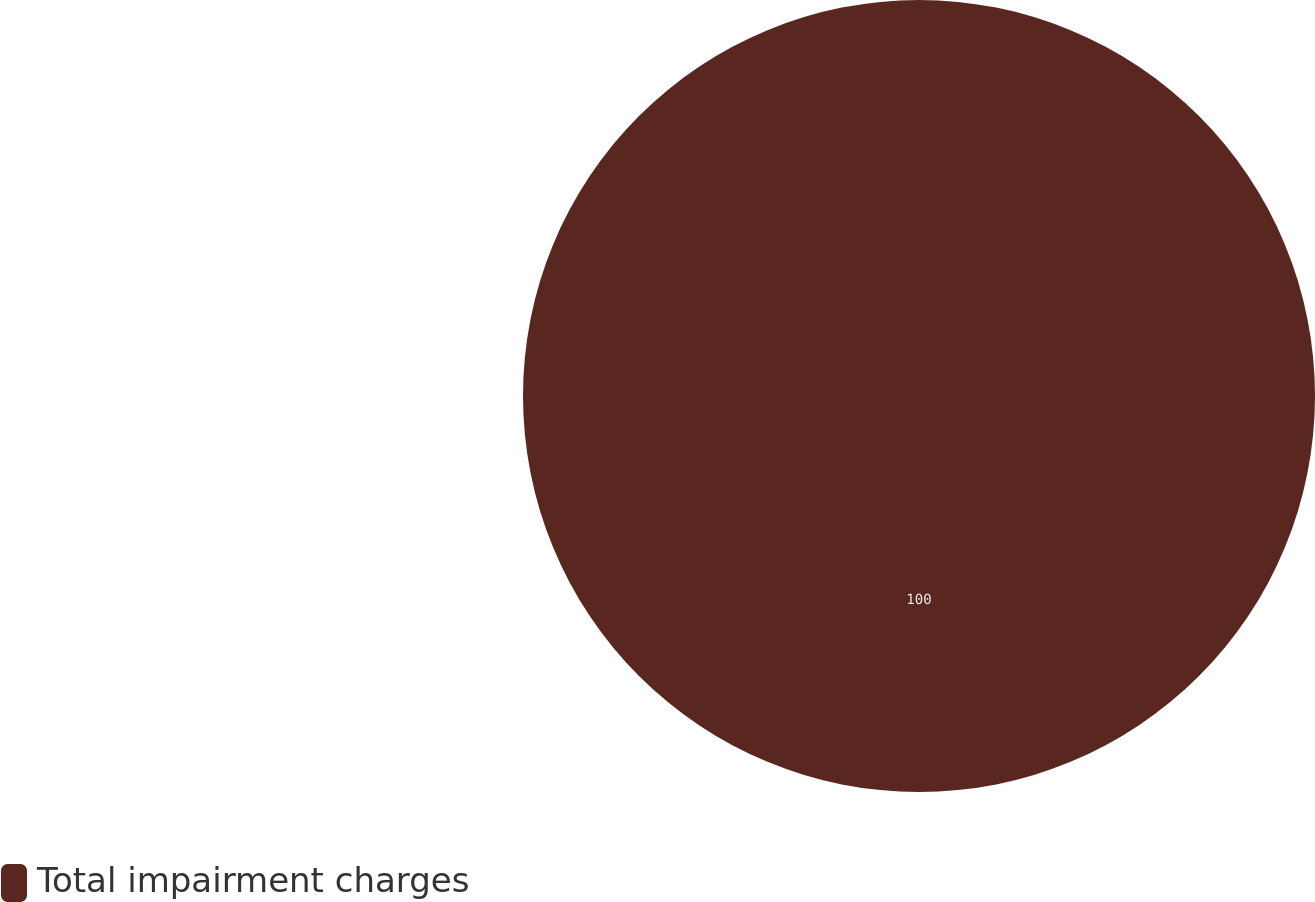<chart> <loc_0><loc_0><loc_500><loc_500><pie_chart><fcel>Total impairment charges<nl><fcel>100.0%<nl></chart> 